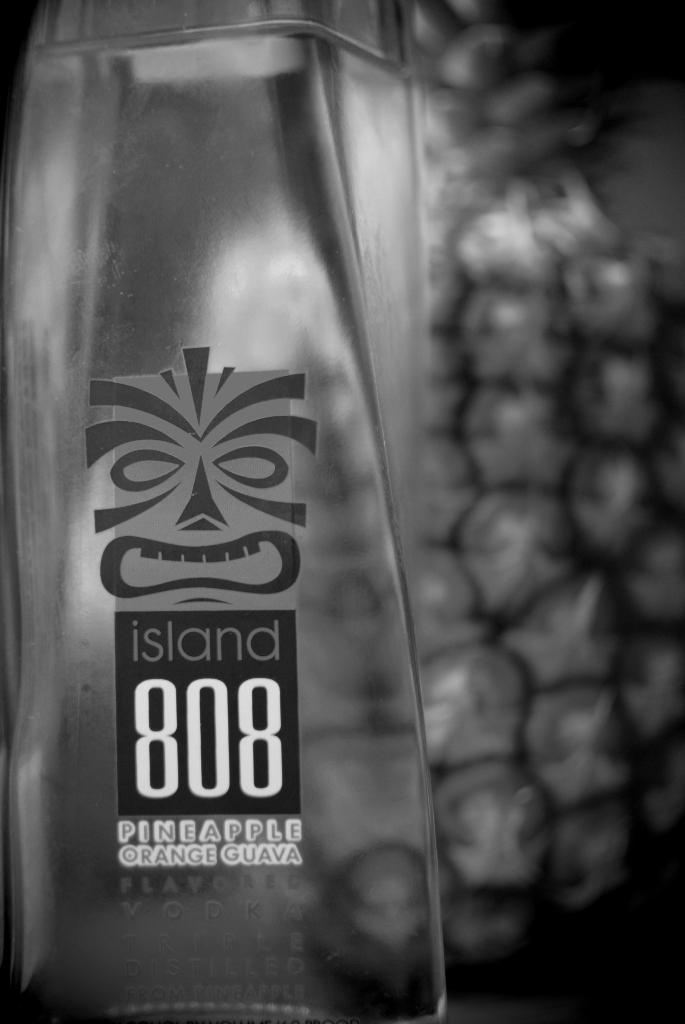What is on the ground in the image? There is a bottle on the ground. What can be seen on the bottle? The bottle has a label on it. How many stars can be seen on the label of the bottle in the image? There is no information about stars on the label of the bottle in the image. 